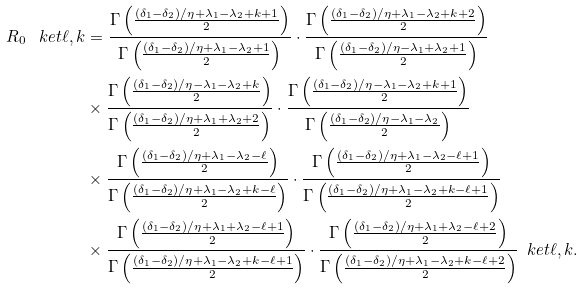Convert formula to latex. <formula><loc_0><loc_0><loc_500><loc_500>R _ { 0 } \, \ k e t { \ell , k } & = \frac { \Gamma \left ( \frac { ( \delta _ { 1 } - \delta _ { 2 } ) / \eta + \lambda _ { 1 } - \lambda _ { 2 } + k + 1 } { 2 } \right ) } { \Gamma \left ( \frac { ( \delta _ { 1 } - \delta _ { 2 } ) / \eta + \lambda _ { 1 } - \lambda _ { 2 } + 1 } { 2 } \right ) } \cdot \frac { \Gamma \left ( \frac { ( \delta _ { 1 } - \delta _ { 2 } ) / \eta + \lambda _ { 1 } - \lambda _ { 2 } + k + 2 } { 2 } \right ) } { \Gamma \left ( \frac { ( \delta _ { 1 } - \delta _ { 2 } ) / \eta - \lambda _ { 1 } + \lambda _ { 2 } + 1 } { 2 } \right ) } \\ & \times \frac { \Gamma \left ( \frac { ( \delta _ { 1 } - \delta _ { 2 } ) / \eta - \lambda _ { 1 } - \lambda _ { 2 } + k } { 2 } \right ) } { \Gamma \left ( \frac { ( \delta _ { 1 } - \delta _ { 2 } ) / \eta + \lambda _ { 1 } + \lambda _ { 2 } + 2 } { 2 } \right ) } \cdot \frac { \Gamma \left ( \frac { ( \delta _ { 1 } - \delta _ { 2 } ) / \eta - \lambda _ { 1 } - \lambda _ { 2 } + k + 1 } { 2 } \right ) } { \Gamma \left ( \frac { ( \delta _ { 1 } - \delta _ { 2 } ) / \eta - \lambda _ { 1 } - \lambda _ { 2 } } { 2 } \right ) } \\ & \times \frac { \Gamma \left ( \frac { ( \delta _ { 1 } - \delta _ { 2 } ) / \eta + \lambda _ { 1 } - \lambda _ { 2 } - \ell } { 2 } \right ) } { \Gamma \left ( \frac { ( \delta _ { 1 } - \delta _ { 2 } ) / \eta + \lambda _ { 1 } - \lambda _ { 2 } + k - \ell } { 2 } \right ) } \cdot \frac { \Gamma \left ( \frac { ( \delta _ { 1 } - \delta _ { 2 } ) / \eta + \lambda _ { 1 } - \lambda _ { 2 } - \ell + 1 } { 2 } \right ) } { \Gamma \left ( \frac { ( \delta _ { 1 } - \delta _ { 2 } ) / \eta + \lambda _ { 1 } - \lambda _ { 2 } + k - \ell + 1 } { 2 } \right ) } \\ & \times \frac { \Gamma \left ( \frac { ( \delta _ { 1 } - \delta _ { 2 } ) / \eta + \lambda _ { 1 } + \lambda _ { 2 } - \ell + 1 } { 2 } \right ) } { \Gamma \left ( \frac { ( \delta _ { 1 } - \delta _ { 2 } ) / \eta + \lambda _ { 1 } - \lambda _ { 2 } + k - \ell + 1 } { 2 } \right ) } \cdot \frac { \Gamma \left ( \frac { ( \delta _ { 1 } - \delta _ { 2 } ) / \eta + \lambda _ { 1 } + \lambda _ { 2 } - \ell + 2 } { 2 } \right ) } { \Gamma \left ( \frac { ( \delta _ { 1 } - \delta _ { 2 } ) / \eta + \lambda _ { 1 } - \lambda _ { 2 } + k - \ell + 2 } { 2 } \right ) } \, \ k e t { \ell , k } .</formula> 